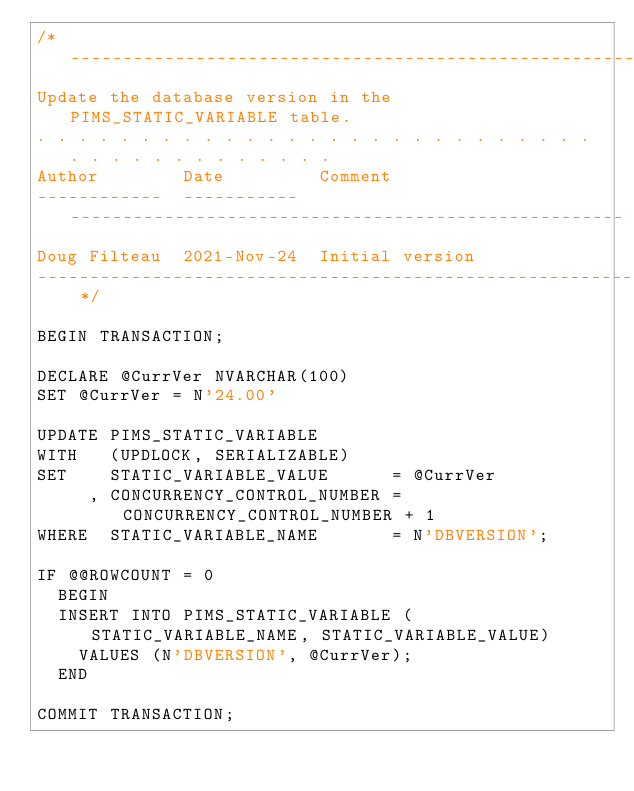Convert code to text. <code><loc_0><loc_0><loc_500><loc_500><_SQL_>/* -----------------------------------------------------------------------------
Update the database version in the PIMS_STATIC_VARIABLE table.
. . . . . . . . . . . . . . . . . . . . . . . . . . . . . . . . . . . . . . . . 
Author        Date         Comment
------------  -----------  -----------------------------------------------------
Doug Filteau  2021-Nov-24  Initial version
----------------------------------------------------------------------------- */

BEGIN TRANSACTION;

DECLARE @CurrVer NVARCHAR(100)
SET @CurrVer = N'24.00'

UPDATE PIMS_STATIC_VARIABLE
WITH   (UPDLOCK, SERIALIZABLE) 
SET    STATIC_VARIABLE_VALUE      = @CurrVer
     , CONCURRENCY_CONTROL_NUMBER = CONCURRENCY_CONTROL_NUMBER + 1
WHERE  STATIC_VARIABLE_NAME       = N'DBVERSION';

IF @@ROWCOUNT = 0
  BEGIN
  INSERT INTO PIMS_STATIC_VARIABLE (STATIC_VARIABLE_NAME, STATIC_VARIABLE_VALUE)
    VALUES (N'DBVERSION', @CurrVer);
  END

COMMIT TRANSACTION;
</code> 